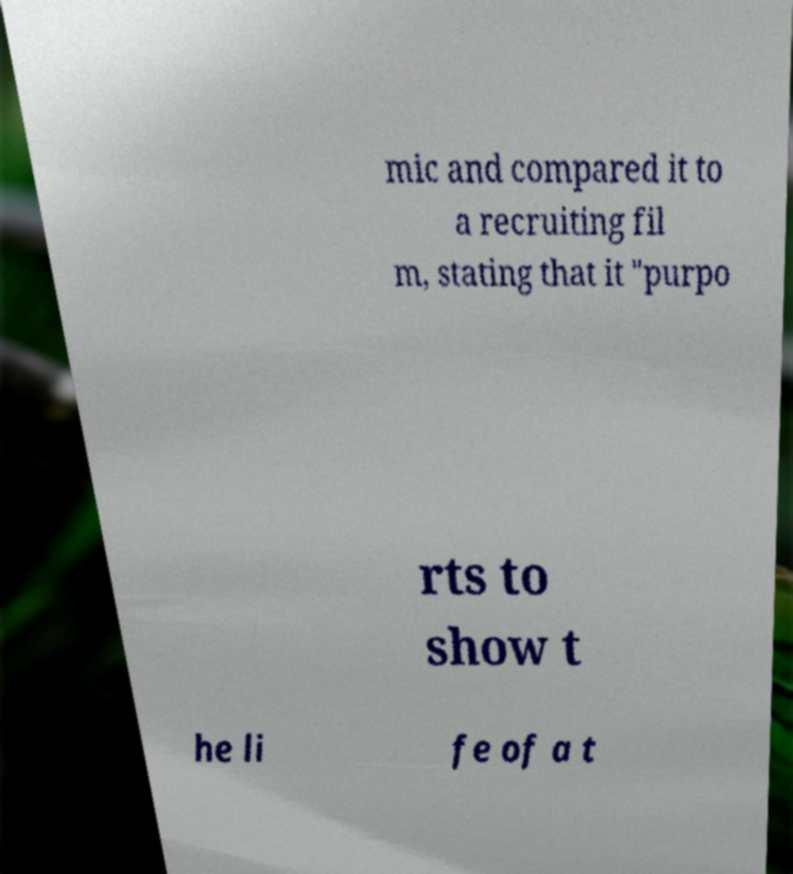Could you assist in decoding the text presented in this image and type it out clearly? mic and compared it to a recruiting fil m, stating that it "purpo rts to show t he li fe of a t 